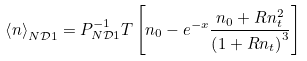Convert formula to latex. <formula><loc_0><loc_0><loc_500><loc_500>\left \langle n \right \rangle _ { N \mathcal { D } 1 } = P _ { N \mathcal { D } 1 } ^ { - 1 } T \left [ n _ { 0 } - e ^ { - x } \frac { n _ { 0 } + R n _ { t } ^ { 2 } } { \left ( 1 + R n _ { t } \right ) ^ { 3 } } \right ]</formula> 